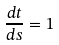Convert formula to latex. <formula><loc_0><loc_0><loc_500><loc_500>\frac { d t } { d s } = 1</formula> 